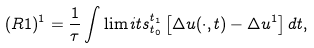Convert formula to latex. <formula><loc_0><loc_0><loc_500><loc_500>( R 1 ) ^ { 1 } = \frac { 1 } { \tau } \int \lim i t s ^ { t _ { 1 } } _ { t _ { 0 } } \left [ \Delta u ( \cdot , t ) - \Delta u ^ { 1 } \right ] d t ,</formula> 